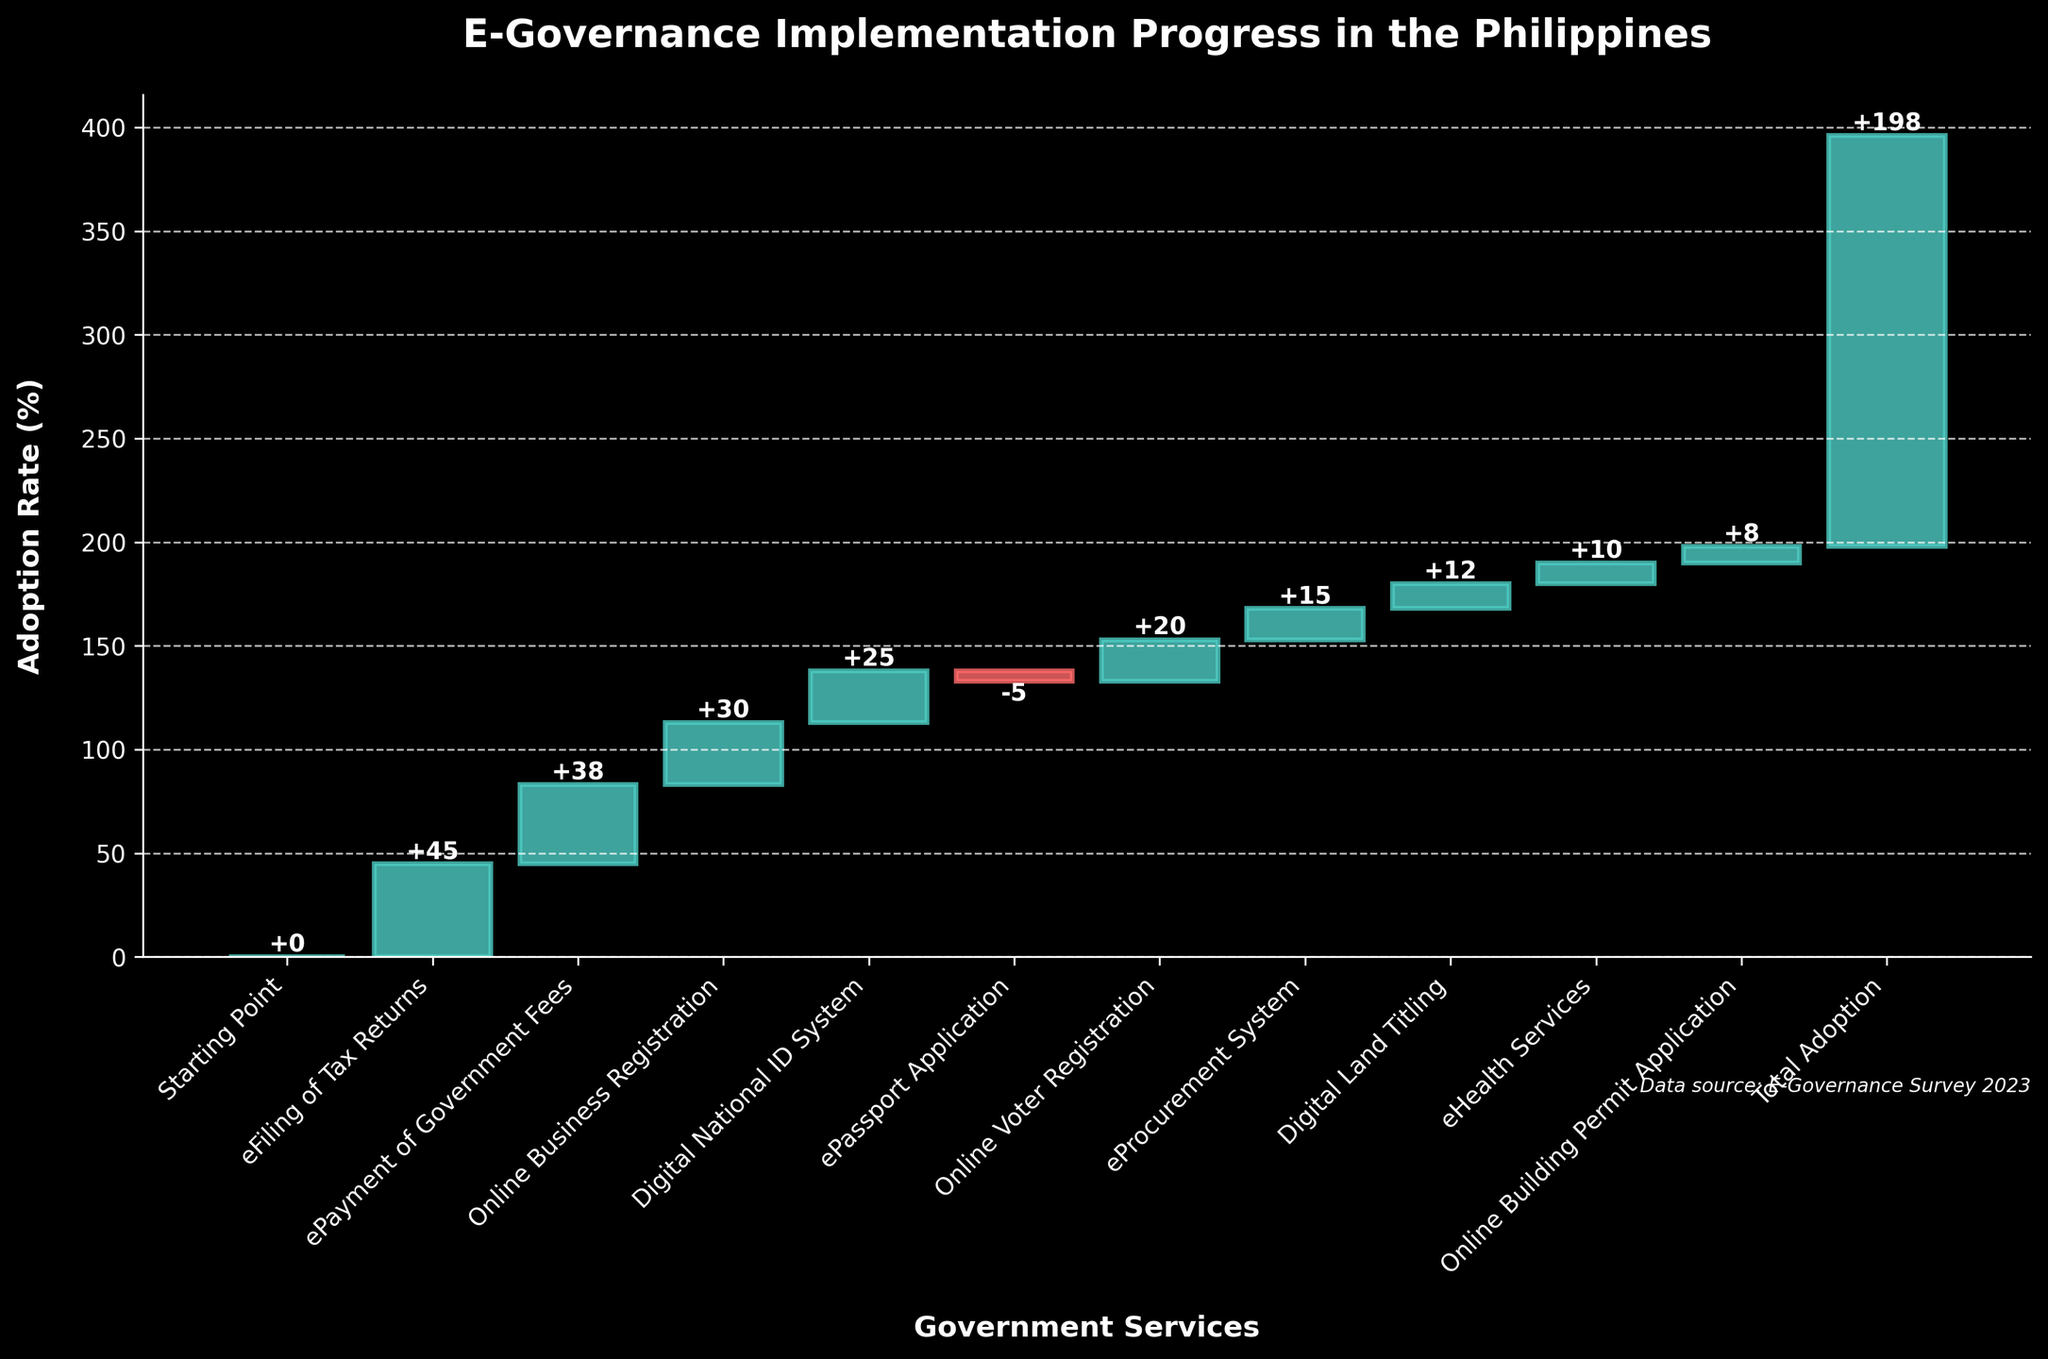What is the title of the chart? The title is typically at the top of the chart. Reading it provides the subject matter the chart covers.
Answer: E-Governance Implementation Progress in the Philippines How many government services are shown in the chart? Count the number of bars or labels on the x-axis to determine the number of different services included in the chart.
Answer: 10 Which government service has the highest adoption rate? Identify the bars with the highest value by comparison. The highest bar represents the service with the greatest adoption rate.
Answer: eFiling of Tax Returns What is the total adoption rate for all services combined? Look for the final cumulative value labeled on the chart, usually called Total Adoption or similar.
Answer: 198% What service has a negative adoption rate, and what is its value? Identify any bars going downward or below the x-axis, indicating a negative value. Read the value directly.
Answer: ePassport Application, -5% By how much did the adoption rate for ePayment of Government Fees differ from Online Business Registration? Subtract the adoption rate of Online Business Registration from the adoption rate of ePayment of Government Fees to find the difference. 38 (ePayment of Government Fees) - 30 (Online Business Registration) = 8
Answer: 8% Which two services contribute equally to the adoption rate? Look for two bars with the same height. In this case, there aren't any exact equals, but most similar could be compared. If none, state none available.
Answer: None available What is the cumulative adoption rate after implementing the Digital National ID System? Add the adoption rates of all services up to and including the Digital National ID System, checking the cumulative value at this point on the chart.
Answer: 138% Which service had an adoption rate slightly lower than Online Voter Registration but higher than eProcurement System? Compare the bars for Online Voter Registration and eProcurement System, and identify the bar that falls in between these values.
Answer: Digital National ID System By how much did the adoption rate increase from the Starting Point to the end total? Subtract the Starting Point adoption rate from the Total Adoption rate. In this case, 0 (Starting Point) to 198 (Total Adoption).
Answer: 198% 